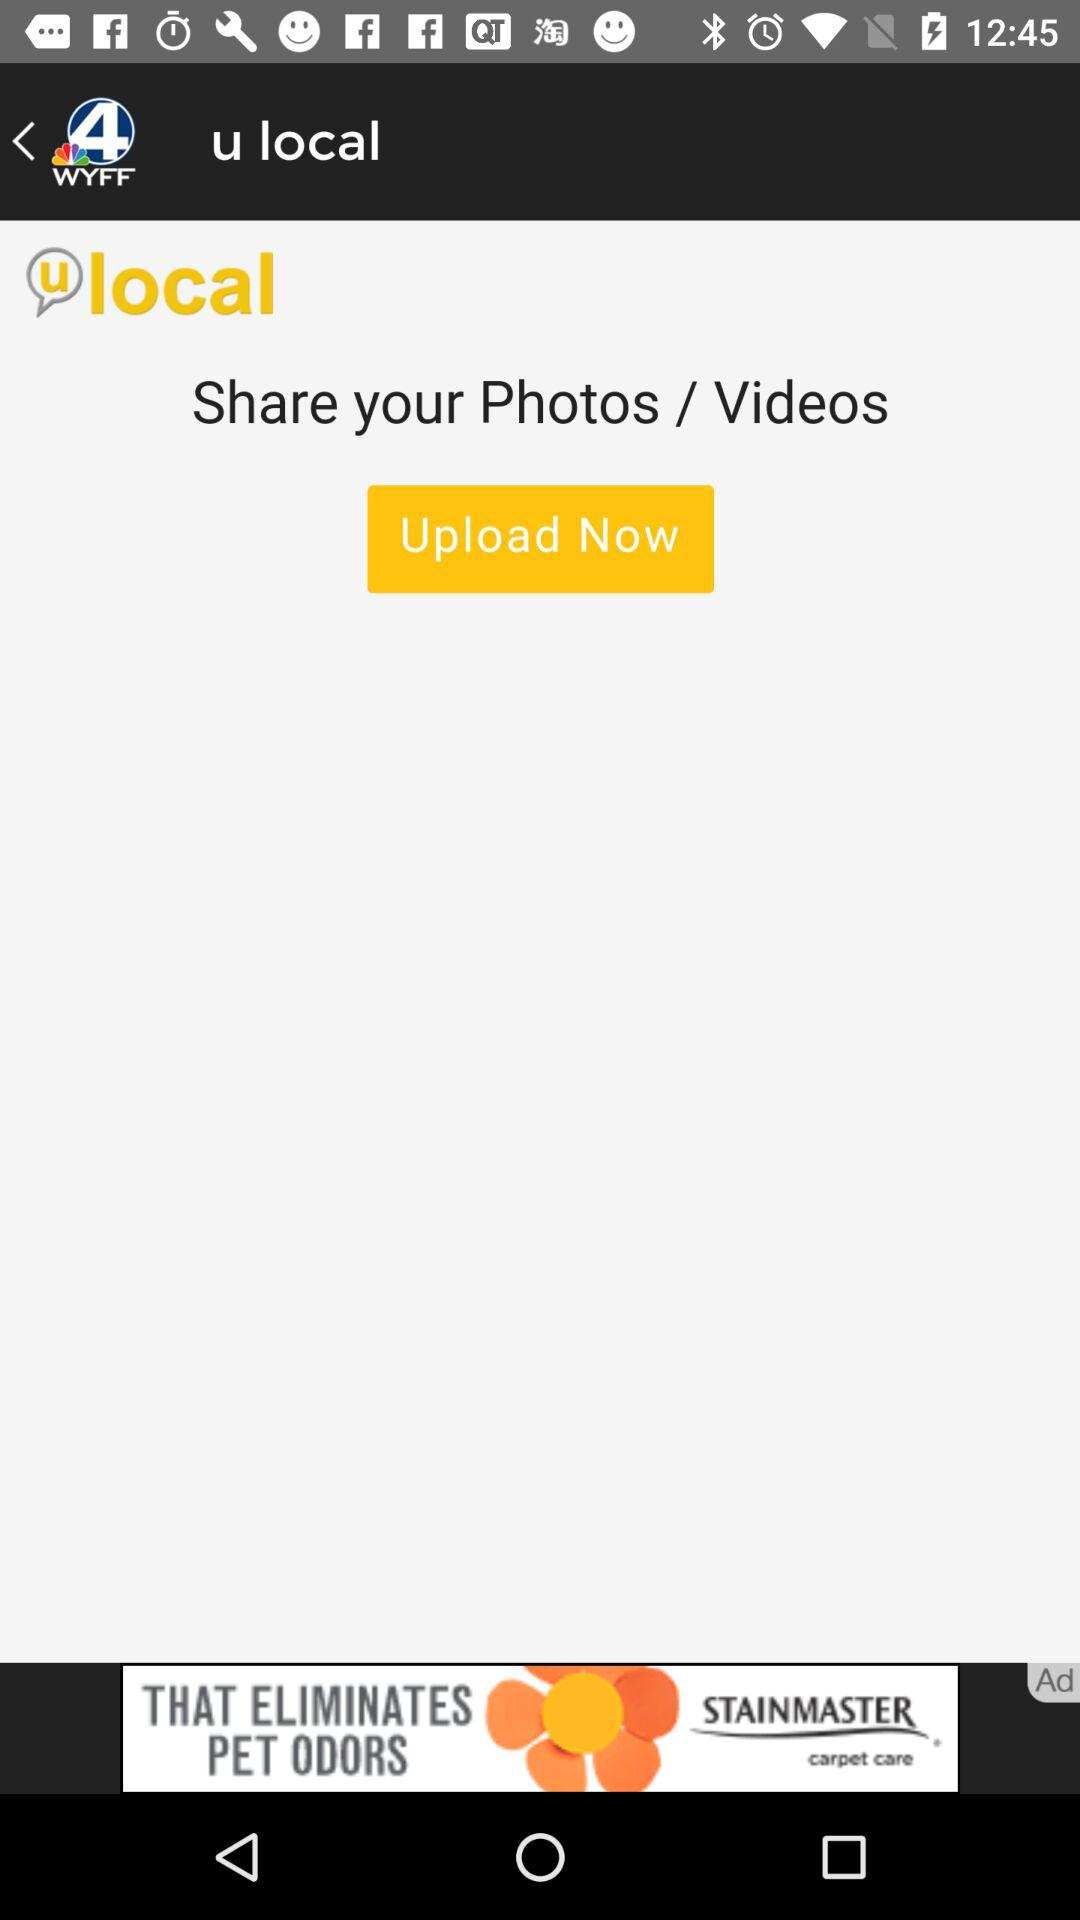How many photos have been shared?
When the provided information is insufficient, respond with <no answer>. <no answer> 